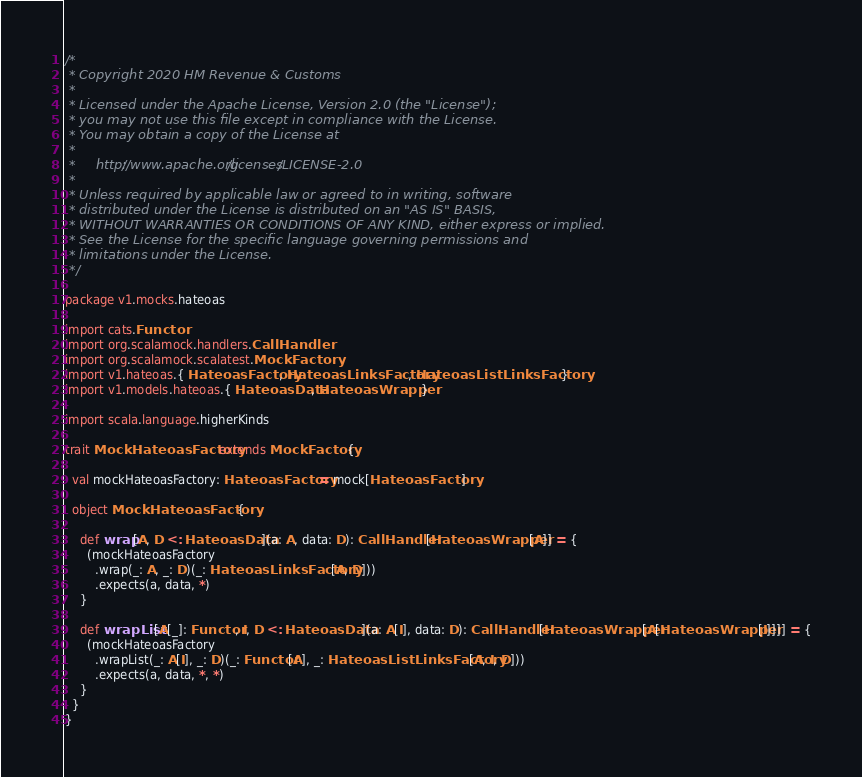Convert code to text. <code><loc_0><loc_0><loc_500><loc_500><_Scala_>/*
 * Copyright 2020 HM Revenue & Customs
 *
 * Licensed under the Apache License, Version 2.0 (the "License");
 * you may not use this file except in compliance with the License.
 * You may obtain a copy of the License at
 *
 *     http://www.apache.org/licenses/LICENSE-2.0
 *
 * Unless required by applicable law or agreed to in writing, software
 * distributed under the License is distributed on an "AS IS" BASIS,
 * WITHOUT WARRANTIES OR CONDITIONS OF ANY KIND, either express or implied.
 * See the License for the specific language governing permissions and
 * limitations under the License.
 */

package v1.mocks.hateoas

import cats.Functor
import org.scalamock.handlers.CallHandler
import org.scalamock.scalatest.MockFactory
import v1.hateoas.{ HateoasFactory, HateoasLinksFactory, HateoasListLinksFactory }
import v1.models.hateoas.{ HateoasData, HateoasWrapper }

import scala.language.higherKinds

trait MockHateoasFactory extends MockFactory {

  val mockHateoasFactory: HateoasFactory = mock[HateoasFactory]

  object MockHateoasFactory {

    def wrap[A, D <: HateoasData](a: A, data: D): CallHandler[HateoasWrapper[A]] = {
      (mockHateoasFactory
        .wrap(_: A, _: D)(_: HateoasLinksFactory[A, D]))
        .expects(a, data, *)
    }

    def wrapList[A[_]: Functor, I, D <: HateoasData](a: A[I], data: D): CallHandler[HateoasWrapper[A[HateoasWrapper[I]]]] = {
      (mockHateoasFactory
        .wrapList(_: A[I], _: D)(_: Functor[A], _: HateoasListLinksFactory[A, I, D]))
        .expects(a, data, *, *)
    }
  }
}
</code> 